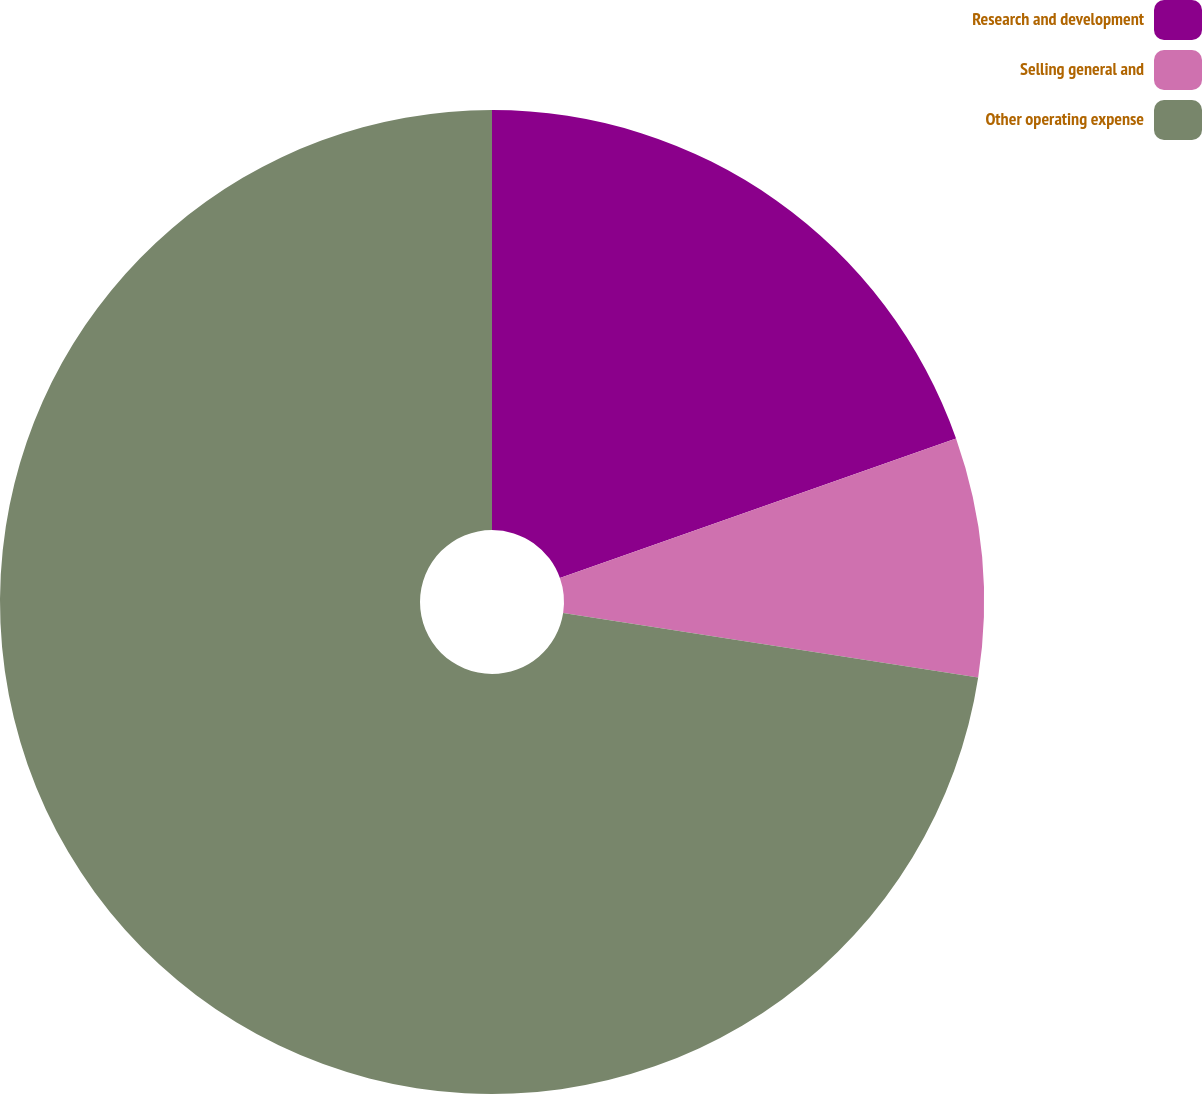<chart> <loc_0><loc_0><loc_500><loc_500><pie_chart><fcel>Research and development<fcel>Selling general and<fcel>Other operating expense<nl><fcel>19.61%<fcel>7.84%<fcel>72.55%<nl></chart> 